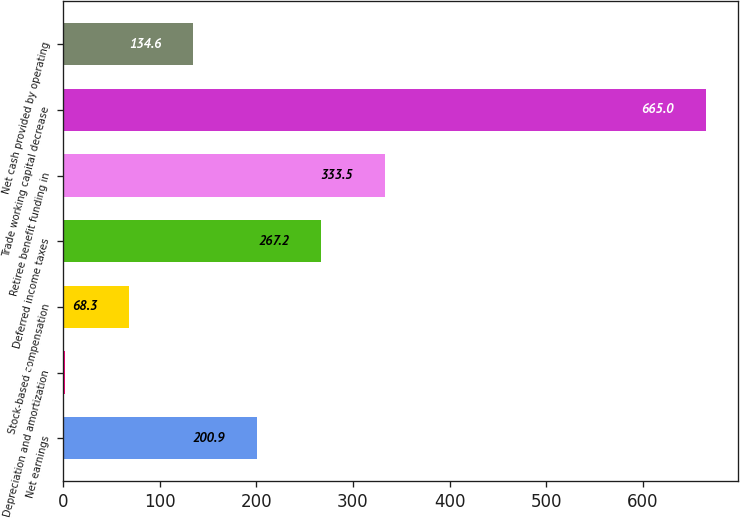<chart> <loc_0><loc_0><loc_500><loc_500><bar_chart><fcel>Net earnings<fcel>Depreciation and amortization<fcel>Stock-based compensation<fcel>Deferred income taxes<fcel>Retiree benefit funding in<fcel>Trade working capital decrease<fcel>Net cash provided by operating<nl><fcel>200.9<fcel>2<fcel>68.3<fcel>267.2<fcel>333.5<fcel>665<fcel>134.6<nl></chart> 